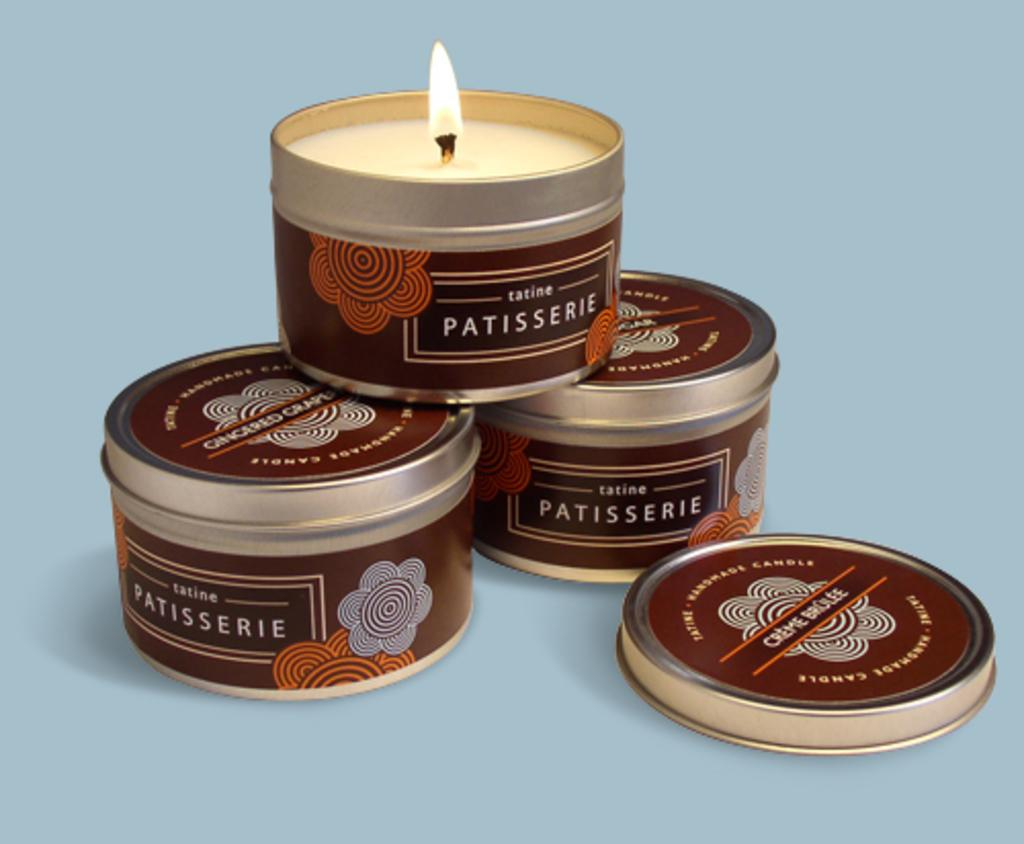How many candle holders are visible in the image? There are three candle holders in the image. What feature do the candle holders have? The candle holders have lids. On what surface are the candle holders placed? The candle holders are placed on a blue surface. What time of day is it in the image, and what color is the gold used in the candle holders? The time of day is not mentioned in the image, and there is no gold used in the candle holders. 